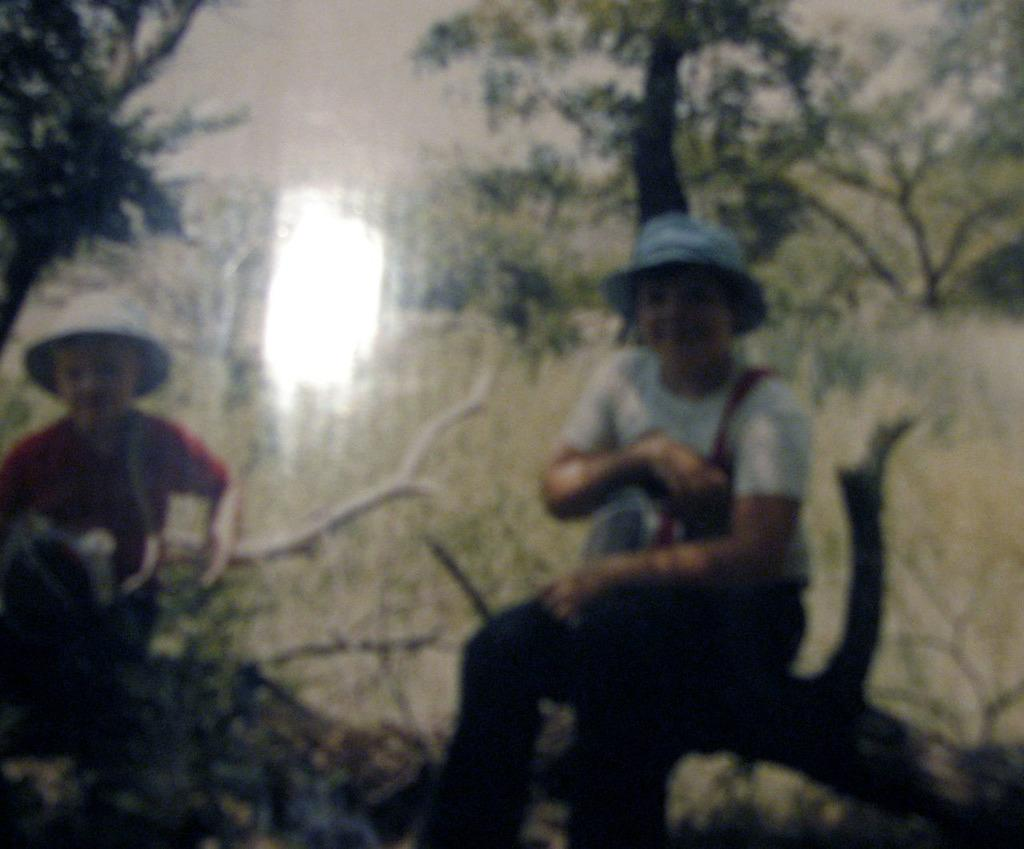How many people are in the image? There are two people in the image. What are the two people doing in the image? The two people are sitting on the branch of a tree. What can be seen in the background of the image? There are trees visible in the background of the image. What type of silk fabric is draped over the branch in the image? There is no silk fabric present in the image; the two people are sitting directly on the branch. 